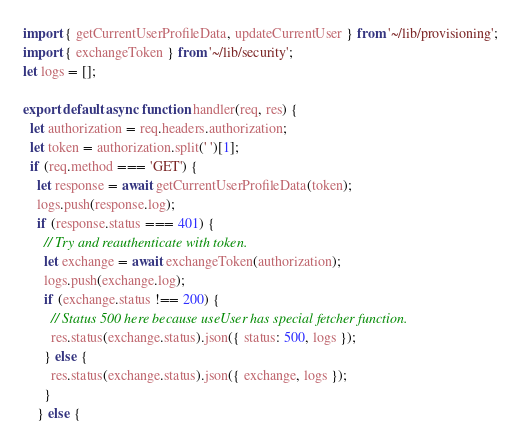Convert code to text. <code><loc_0><loc_0><loc_500><loc_500><_JavaScript_>import { getCurrentUserProfileData, updateCurrentUser } from '~/lib/provisioning';
import { exchangeToken } from '~/lib/security';
let logs = [];

export default async function handler(req, res) {
  let authorization = req.headers.authorization;
  let token = authorization.split(' ')[1];
  if (req.method === 'GET') {
    let response = await getCurrentUserProfileData(token);
    logs.push(response.log);
    if (response.status === 401) {
      // Try and reauthenticate with token.
      let exchange = await exchangeToken(authorization);
      logs.push(exchange.log);
      if (exchange.status !== 200) {
        // Status 500 here because useUser has special fetcher function.
        res.status(exchange.status).json({ status: 500, logs });
      } else {
        res.status(exchange.status).json({ exchange, logs });
      }
    } else {</code> 